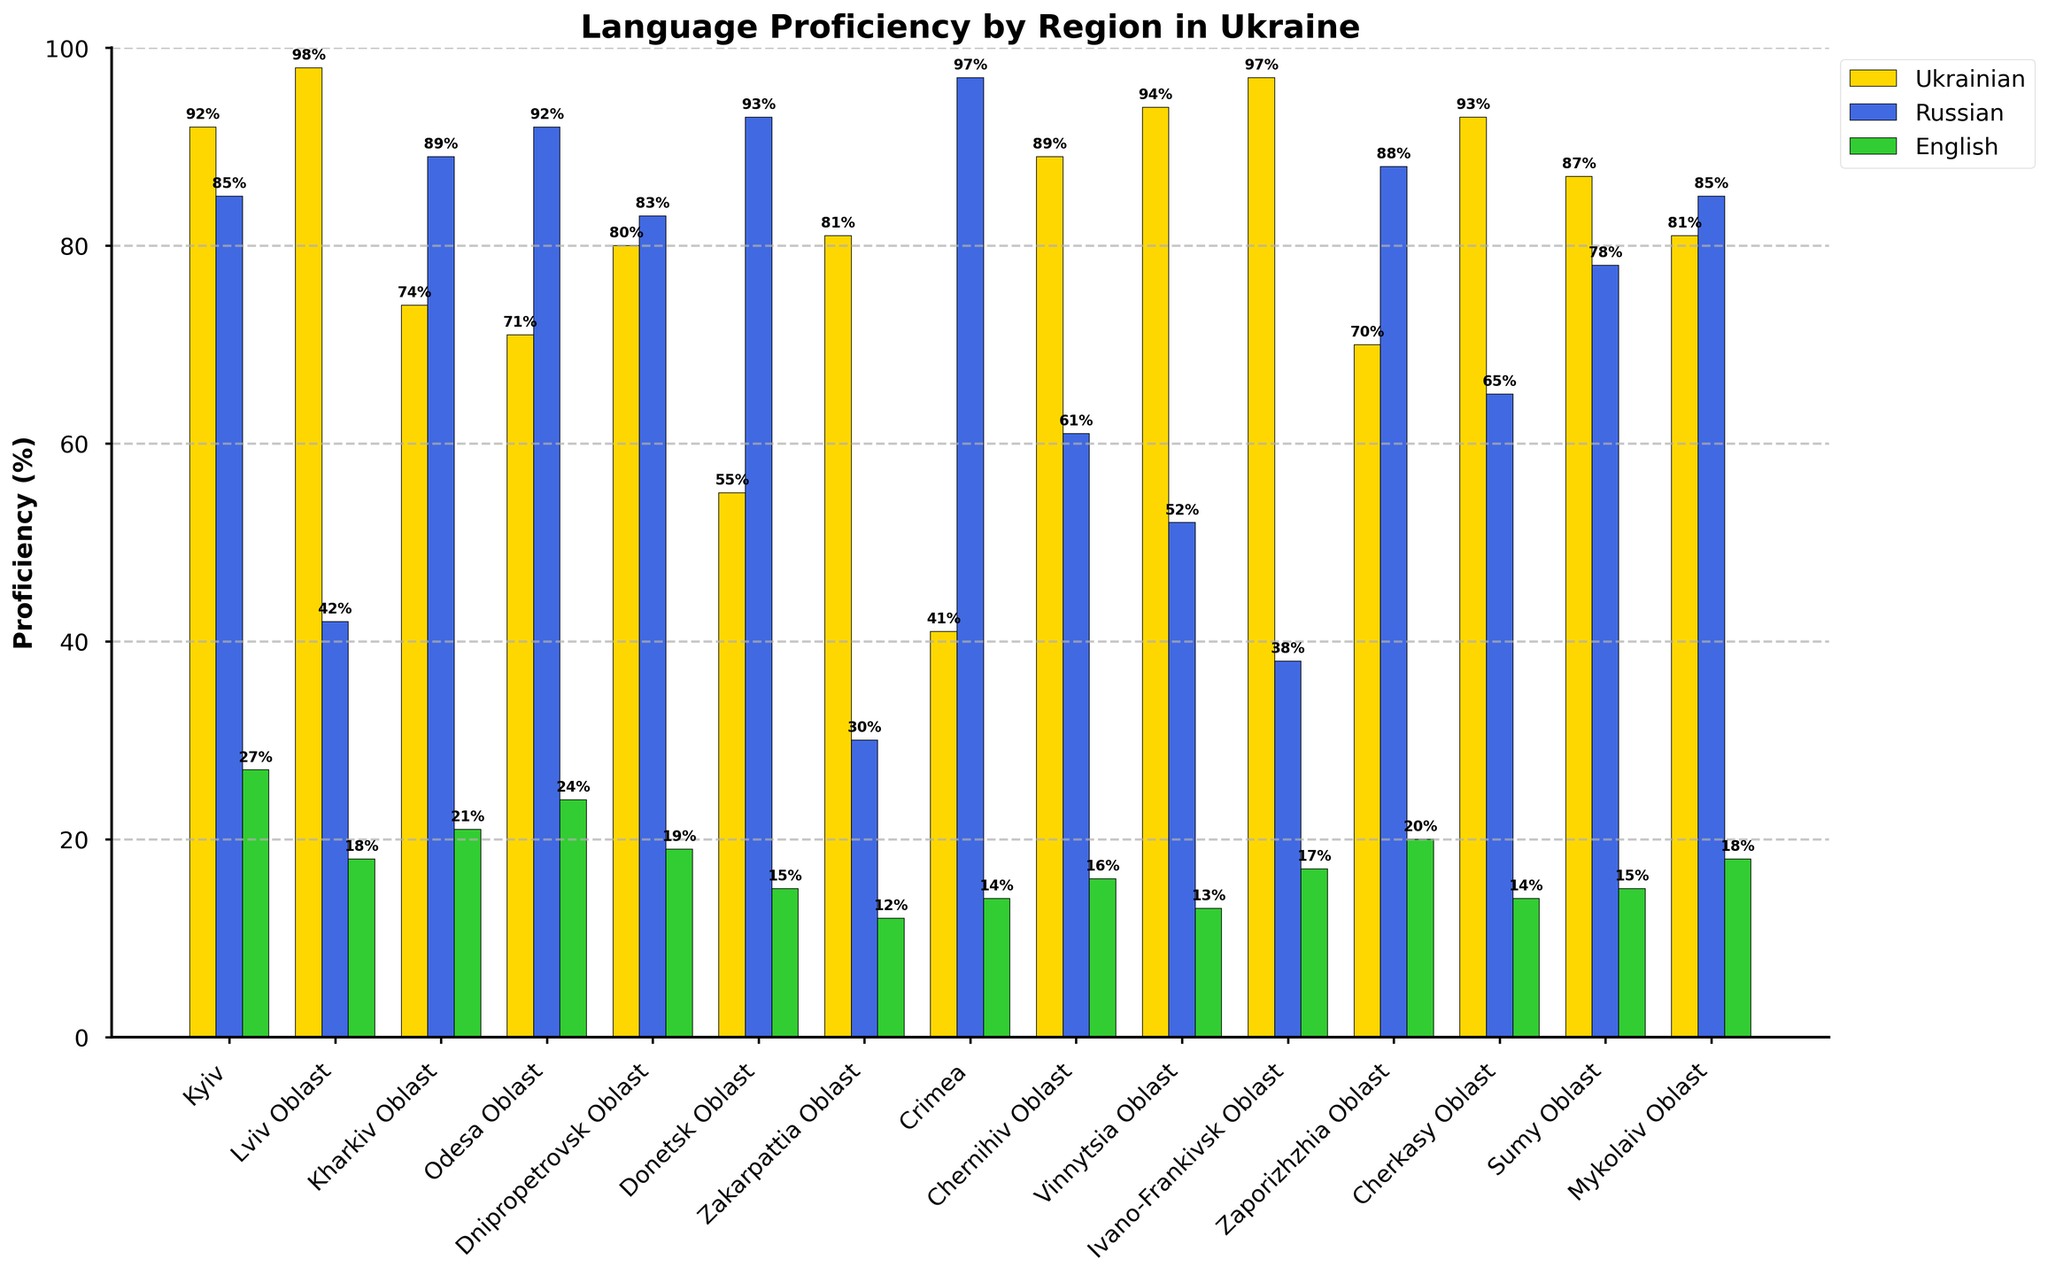What region has the highest proficiency in Russian? Check each bar for Russian proficiency in the figure and identify the highest bar. The Crimea region has the highest proficiency at 97%.
Answer: Crimea Which language has the lowest average proficiency across all regions? Calculate the average proficiency for each language by summing the percentages and dividing by the number of regions. Ukrainian: (92 + 98 + 74 + 71 + 80 + 55 + 81 + 41 + 89 + 94 + 97 + 70 + 93 + 87 + 81)/15 = 79.13. Russian: (85 + 42 + 89 + 92 + 83 + 93 + 30 + 97 + 61 + 52 + 38 + 88 + 65 + 78 + 85)/15 = 71.67. English: (27 + 18 + 21 + 24 + 19 + 15 + 12 + 14 + 16 + 13 + 17 + 20 + 14 + 15 + 18)/15 = 17.93. Thus, English has the lowest average proficiency.
Answer: English Is Russian proficiency generally higher in eastern regions compared to western regions? Compare regions generally considered eastern (Kharkiv Oblast, Odesa Oblast, Donetsk Oblast, Zaporizhzhia Oblast) with western (Lviv Oblast, Ivano-Frankivsk Oblast, Zakarpattia Oblast). Eastern regions: Kharkiv Oblast (89), Odesa Oblast (92), Donetsk Oblast (93), Zaporizhzhia Oblast (88). Western regions: Lviv Oblast (42), Ivano-Frankivsk Oblast (38), Zakarpattia Oblast (30). Russian proficiency is notably higher in eastern regions compared to western ones.
Answer: Yes What is the sum of English proficiency percentages for the three regions with the lowest Ukrainian proficiency? Identify the three lowest Ukrainian proficiency regions (Crimea 41, Donetsk Oblast 55, Odesa Oblast 71). Sum their English proficiencies (Crimea 14, Donetsk Oblast 15, Odesa Oblast 24): 14 + 15 + 24 = 53.
Answer: 53 Which region exhibits the highest proficiency in any of the languages? Identify the highest bar for each region and compare them. Ukrainian proficiency in Lviv Oblast and Ivano-Frankivsk Oblast both reach 98%.
Answer: Lviv Oblast and Ivano-Frankivsk Oblast 